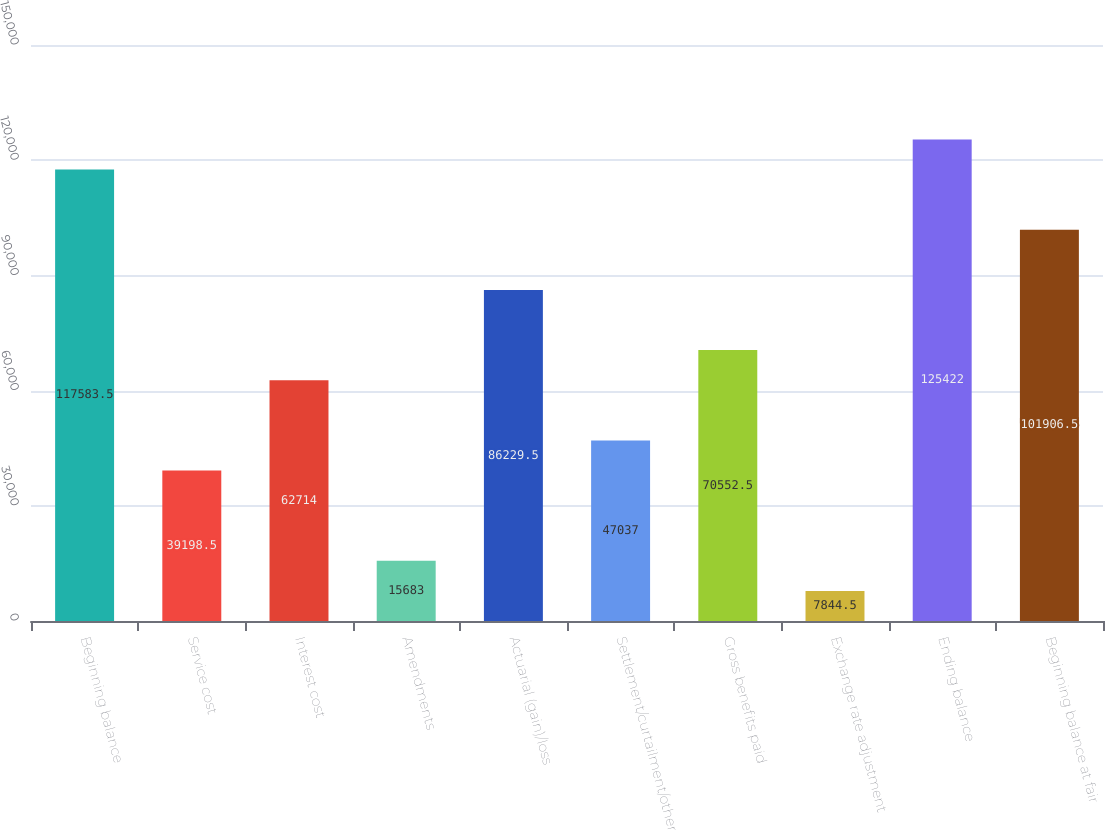Convert chart to OTSL. <chart><loc_0><loc_0><loc_500><loc_500><bar_chart><fcel>Beginning balance<fcel>Service cost<fcel>Interest cost<fcel>Amendments<fcel>Actuarial (gain)/loss<fcel>Settlement/curtailment/other<fcel>Gross benefits paid<fcel>Exchange rate adjustment<fcel>Ending balance<fcel>Beginning balance at fair<nl><fcel>117584<fcel>39198.5<fcel>62714<fcel>15683<fcel>86229.5<fcel>47037<fcel>70552.5<fcel>7844.5<fcel>125422<fcel>101906<nl></chart> 